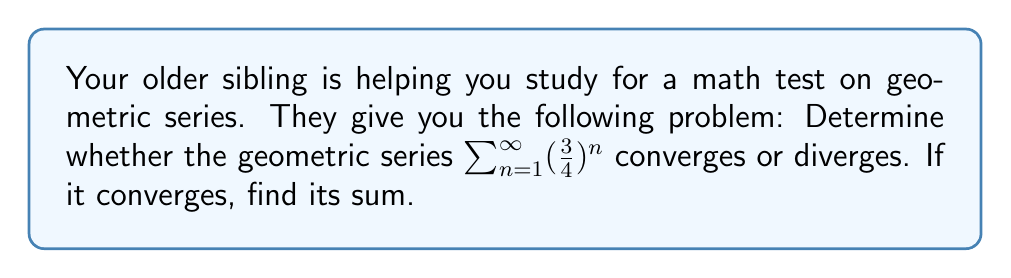Solve this math problem. Let's approach this step-by-step:

1) First, recall that for a geometric series $\sum_{n=1}^{\infty} ar^n$, where $a$ is the first term and $r$ is the common ratio:
   - The series converges if $|r| < 1$
   - The series diverges if $|r| \geq 1$

2) In our series $\sum_{n=1}^{\infty} (\frac{3}{4})^n$, we can identify:
   $a = \frac{3}{4}$ (first term when $n=1$)
   $r = \frac{3}{4}$ (common ratio)

3) Let's check if $|r| < 1$:
   $|\frac{3}{4}| = \frac{3}{4} = 0.75 < 1$

4) Since $|r| < 1$, the series converges.

5) For a converging geometric series, we can find the sum using the formula:
   $S_{\infty} = \frac{a}{1-r}$, where $S_{\infty}$ is the sum of the infinite series

6) Substituting our values:
   $S_{\infty} = \frac{\frac{3}{4}}{1-\frac{3}{4}} = \frac{\frac{3}{4}}{\frac{1}{4}} = 3$

Therefore, the series converges, and its sum is 3.
Answer: Converges; Sum = 3 